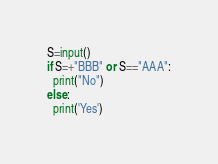Convert code to text. <code><loc_0><loc_0><loc_500><loc_500><_Python_>S=input()
if S=+"BBB" or S=="AAA":
  print("No")
else:
  print('Yes')</code> 